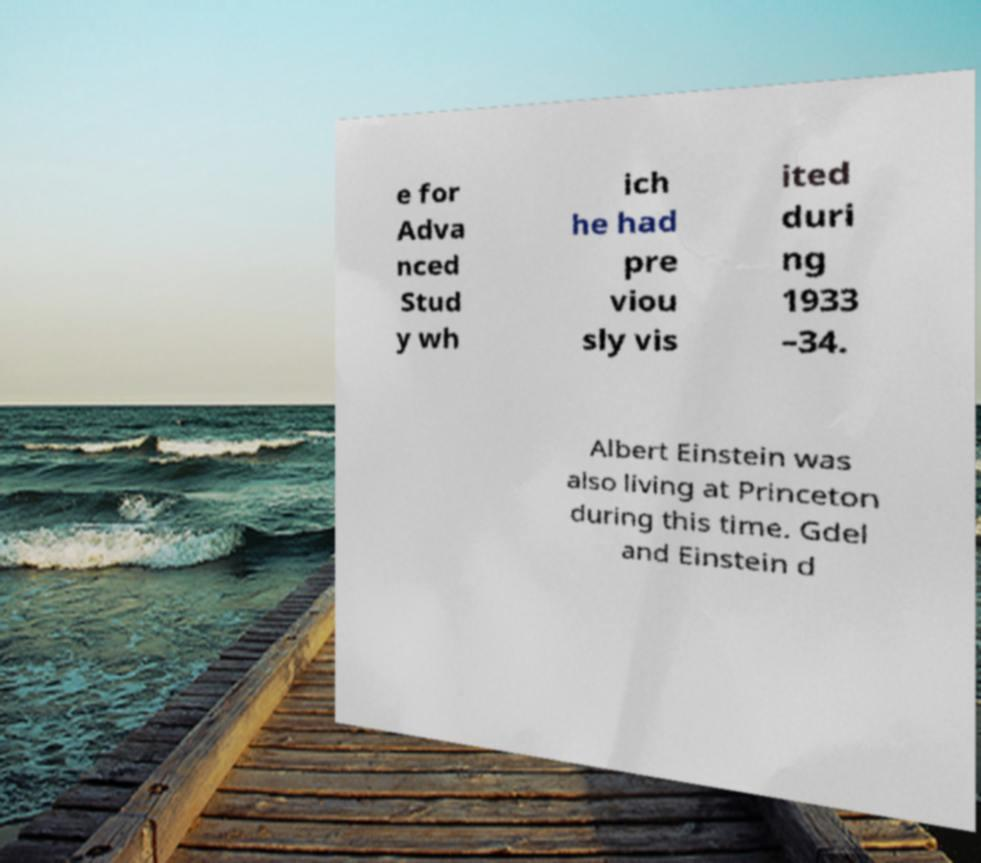Could you extract and type out the text from this image? e for Adva nced Stud y wh ich he had pre viou sly vis ited duri ng 1933 –34. Albert Einstein was also living at Princeton during this time. Gdel and Einstein d 